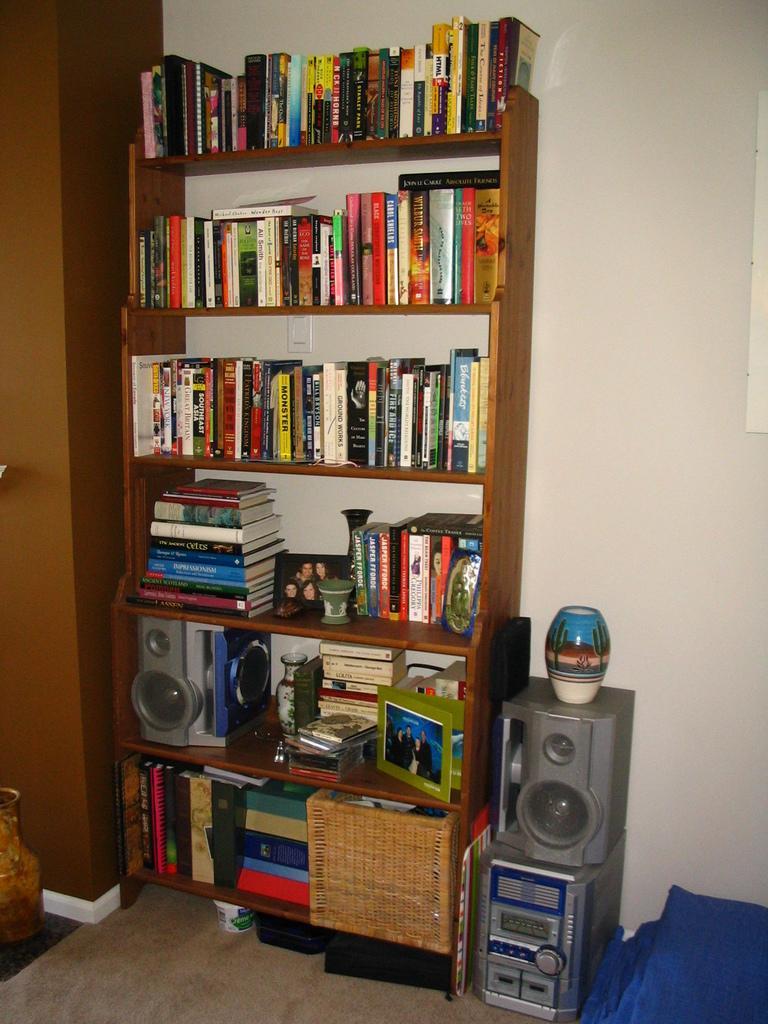In one or two sentences, can you explain what this image depicts? In this image there is a wall, in front of the wall, there is a rack in which there are some books,speakers, beside the rock there are speakers on which there is a glass object, cloth,on the left side maybe there is a cabinet, pot. 